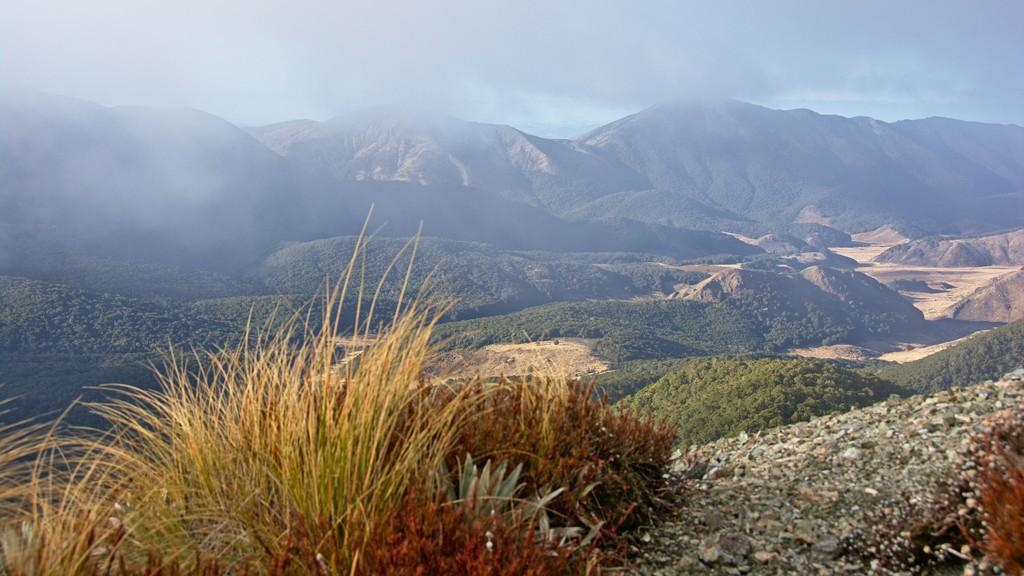What type of vegetation can be seen in the image? There are plants and grass visible in the image. What is the terrain like in the image? The land is visible in the image. What can be seen in the background of the image? There are hills in the background of the image. How are the hills covered? The hills are covered with plants. What is visible above the land and hills in the image? The sky is visible in the image. What can be observed in the sky? Clouds are present in the sky. How many nuts are scattered on the ground in the image? There are no nuts visible in the image. What type of wind can be seen blowing through the image? There is no wind visible in the image, and the term "zephyr" refers to a gentle breeze, which cannot be seen. 